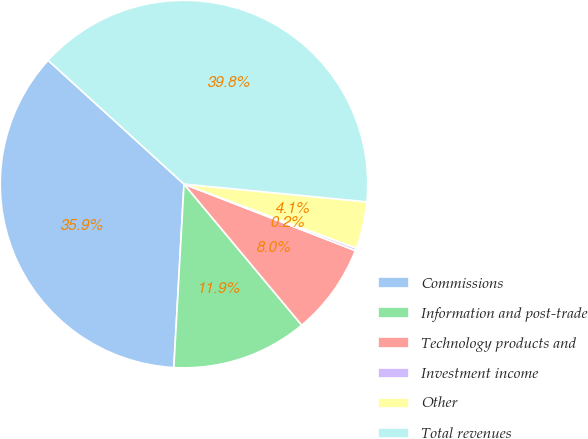Convert chart to OTSL. <chart><loc_0><loc_0><loc_500><loc_500><pie_chart><fcel>Commissions<fcel>Information and post-trade<fcel>Technology products and<fcel>Investment income<fcel>Other<fcel>Total revenues<nl><fcel>35.88%<fcel>11.95%<fcel>8.04%<fcel>0.22%<fcel>4.13%<fcel>39.79%<nl></chart> 